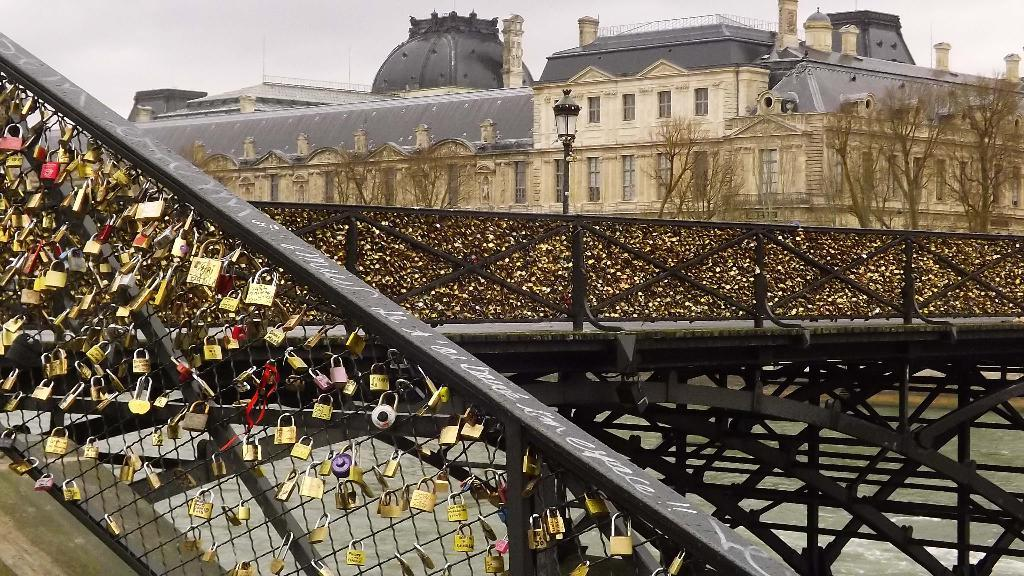What structure is the main focus of the image? There is a trestle in the image. Are there any specific features on the trestle? Yes, there are locks on the trestle. What type of natural elements can be seen in the image? There are trees in the image. What type of man-made structures are visible at the top side of the image? There are buildings at the top side of the image. What does the sister of the person taking the picture desire in the image? There is no person taking the picture mentioned in the facts, and therefore no sister or desire can be determined from the image. 